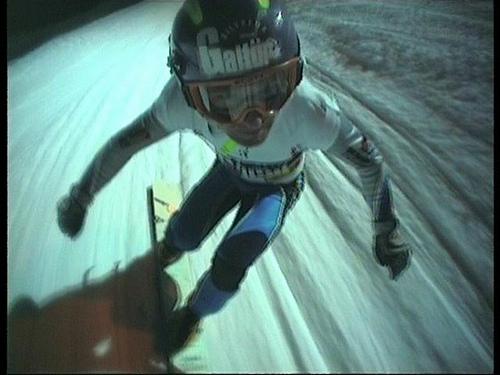Is the man a professional athlete?
Keep it brief. Yes. What is the man wearing on top of his head?
Keep it brief. Helmet. Is this snowboarder going down a hill?
Answer briefly. Yes. 